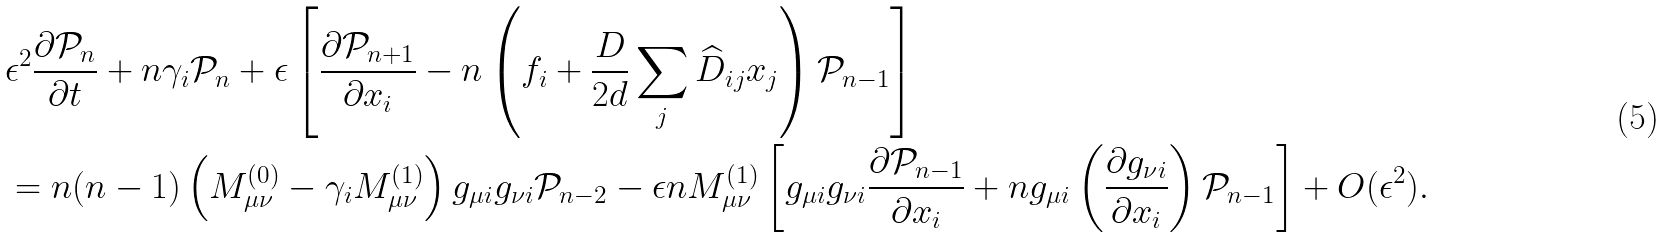<formula> <loc_0><loc_0><loc_500><loc_500>& \epsilon ^ { 2 } \frac { \partial { \mathcal { P } } _ { n } } { \partial t } + n \gamma _ { i } { \mathcal { P } } _ { n } + \epsilon \left [ \frac { \partial { \mathcal { P } } _ { n + 1 } } { \partial x _ { i } } - n \left ( f _ { i } + \frac { D } { 2 d } \sum _ { j } \widehat { D } _ { i j } x _ { j } \right ) { \mathcal { P } } _ { n - 1 } \right ] \\ & = n ( n - 1 ) \left ( M ^ { ( 0 ) } _ { \mu \nu } - \gamma _ { i } M ^ { ( 1 ) } _ { \mu \nu } \right ) g _ { \mu i } g _ { \nu i } { \mathcal { P } } _ { n - 2 } - \epsilon n M ^ { ( 1 ) } _ { \mu \nu } \left [ g _ { \mu i } g _ { \nu i } \frac { \partial { \mathcal { P } } _ { n - 1 } } { \partial x _ { i } } + n g _ { \mu i } \left ( \frac { \partial g _ { \nu i } } { \partial x _ { i } } \right ) { \mathcal { P } } _ { n - 1 } \right ] + O ( \epsilon ^ { 2 } ) .</formula> 